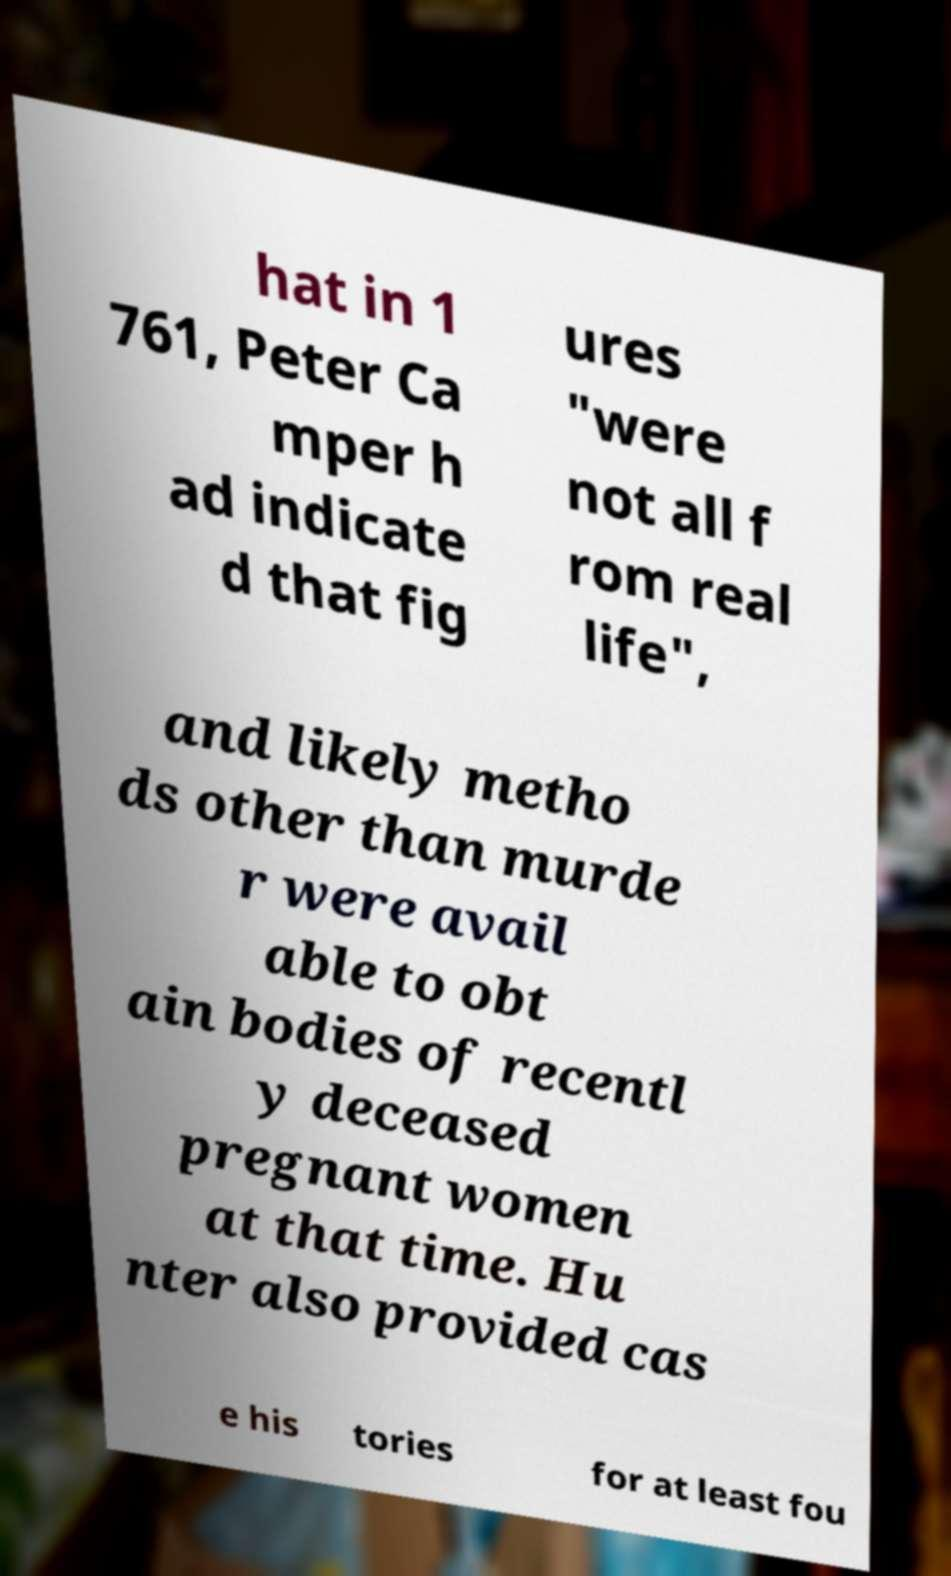Please identify and transcribe the text found in this image. hat in 1 761, Peter Ca mper h ad indicate d that fig ures "were not all f rom real life", and likely metho ds other than murde r were avail able to obt ain bodies of recentl y deceased pregnant women at that time. Hu nter also provided cas e his tories for at least fou 